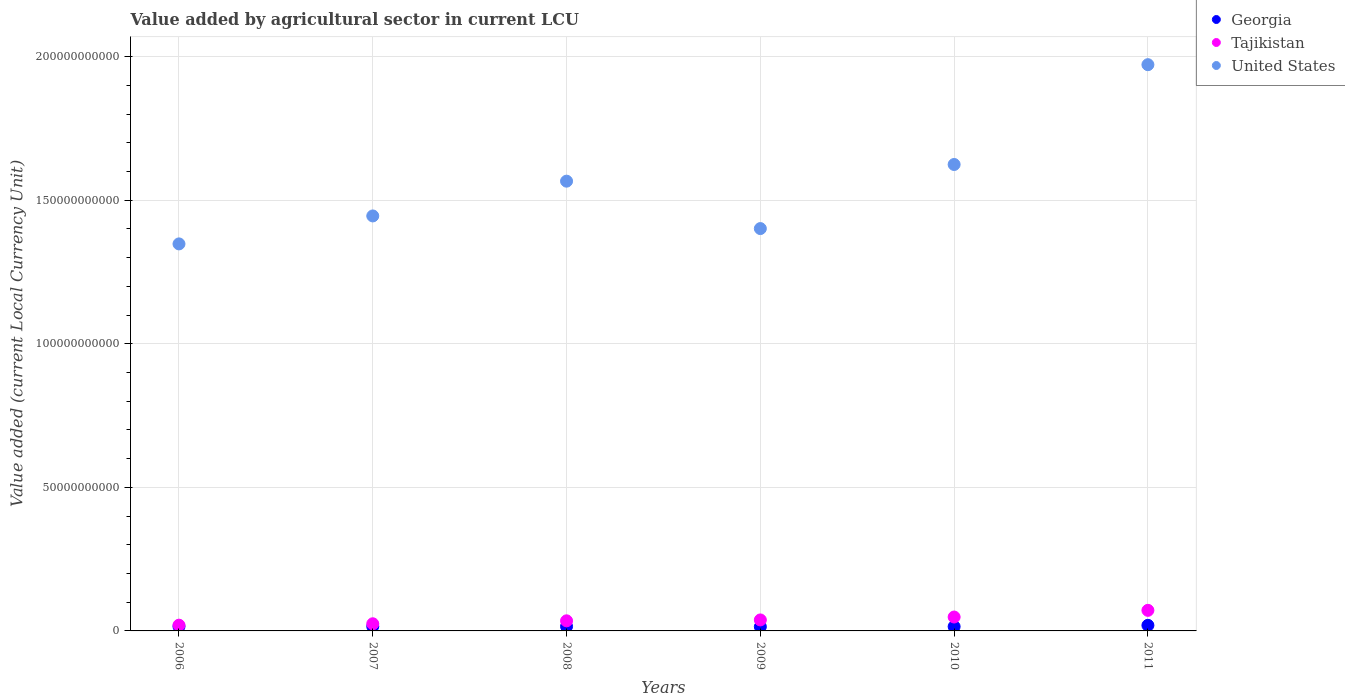What is the value added by agricultural sector in Tajikistan in 2010?
Provide a succinct answer. 4.84e+09. Across all years, what is the maximum value added by agricultural sector in United States?
Your answer should be very brief. 1.97e+11. Across all years, what is the minimum value added by agricultural sector in Tajikistan?
Give a very brief answer. 2.00e+09. What is the total value added by agricultural sector in Tajikistan in the graph?
Your answer should be very brief. 2.38e+1. What is the difference between the value added by agricultural sector in Tajikistan in 2009 and that in 2010?
Keep it short and to the point. -1.01e+09. What is the difference between the value added by agricultural sector in Tajikistan in 2011 and the value added by agricultural sector in Georgia in 2010?
Your response must be concise. 5.66e+09. What is the average value added by agricultural sector in Tajikistan per year?
Your response must be concise. 3.97e+09. In the year 2010, what is the difference between the value added by agricultural sector in United States and value added by agricultural sector in Georgia?
Give a very brief answer. 1.61e+11. What is the ratio of the value added by agricultural sector in Tajikistan in 2007 to that in 2009?
Your answer should be compact. 0.65. Is the value added by agricultural sector in Tajikistan in 2007 less than that in 2010?
Make the answer very short. Yes. Is the difference between the value added by agricultural sector in United States in 2009 and 2010 greater than the difference between the value added by agricultural sector in Georgia in 2009 and 2010?
Provide a short and direct response. No. What is the difference between the highest and the second highest value added by agricultural sector in Tajikistan?
Offer a very short reply. 2.33e+09. What is the difference between the highest and the lowest value added by agricultural sector in Tajikistan?
Your answer should be compact. 5.17e+09. How many dotlines are there?
Your answer should be compact. 3. How many years are there in the graph?
Offer a very short reply. 6. Does the graph contain any zero values?
Provide a succinct answer. No. Where does the legend appear in the graph?
Ensure brevity in your answer.  Top right. How are the legend labels stacked?
Your answer should be compact. Vertical. What is the title of the graph?
Provide a succinct answer. Value added by agricultural sector in current LCU. Does "Lithuania" appear as one of the legend labels in the graph?
Your answer should be very brief. No. What is the label or title of the X-axis?
Offer a terse response. Years. What is the label or title of the Y-axis?
Give a very brief answer. Value added (current Local Currency Unit). What is the Value added (current Local Currency Unit) of Georgia in 2006?
Your response must be concise. 1.54e+09. What is the Value added (current Local Currency Unit) in Tajikistan in 2006?
Your answer should be very brief. 2.00e+09. What is the Value added (current Local Currency Unit) in United States in 2006?
Offer a terse response. 1.35e+11. What is the Value added (current Local Currency Unit) of Georgia in 2007?
Your answer should be compact. 1.56e+09. What is the Value added (current Local Currency Unit) of Tajikistan in 2007?
Keep it short and to the point. 2.49e+09. What is the Value added (current Local Currency Unit) in United States in 2007?
Your answer should be very brief. 1.45e+11. What is the Value added (current Local Currency Unit) in Georgia in 2008?
Provide a short and direct response. 1.55e+09. What is the Value added (current Local Currency Unit) of Tajikistan in 2008?
Offer a terse response. 3.52e+09. What is the Value added (current Local Currency Unit) of United States in 2008?
Ensure brevity in your answer.  1.57e+11. What is the Value added (current Local Currency Unit) of Georgia in 2009?
Ensure brevity in your answer.  1.46e+09. What is the Value added (current Local Currency Unit) of Tajikistan in 2009?
Ensure brevity in your answer.  3.83e+09. What is the Value added (current Local Currency Unit) in United States in 2009?
Keep it short and to the point. 1.40e+11. What is the Value added (current Local Currency Unit) of Georgia in 2010?
Keep it short and to the point. 1.51e+09. What is the Value added (current Local Currency Unit) in Tajikistan in 2010?
Offer a terse response. 4.84e+09. What is the Value added (current Local Currency Unit) of United States in 2010?
Provide a succinct answer. 1.62e+11. What is the Value added (current Local Currency Unit) of Georgia in 2011?
Your answer should be compact. 1.95e+09. What is the Value added (current Local Currency Unit) of Tajikistan in 2011?
Give a very brief answer. 7.17e+09. What is the Value added (current Local Currency Unit) of United States in 2011?
Offer a terse response. 1.97e+11. Across all years, what is the maximum Value added (current Local Currency Unit) in Georgia?
Offer a terse response. 1.95e+09. Across all years, what is the maximum Value added (current Local Currency Unit) in Tajikistan?
Offer a very short reply. 7.17e+09. Across all years, what is the maximum Value added (current Local Currency Unit) in United States?
Offer a terse response. 1.97e+11. Across all years, what is the minimum Value added (current Local Currency Unit) in Georgia?
Your answer should be compact. 1.46e+09. Across all years, what is the minimum Value added (current Local Currency Unit) in Tajikistan?
Your response must be concise. 2.00e+09. Across all years, what is the minimum Value added (current Local Currency Unit) in United States?
Offer a very short reply. 1.35e+11. What is the total Value added (current Local Currency Unit) of Georgia in the graph?
Your answer should be very brief. 9.57e+09. What is the total Value added (current Local Currency Unit) of Tajikistan in the graph?
Provide a succinct answer. 2.38e+1. What is the total Value added (current Local Currency Unit) in United States in the graph?
Your response must be concise. 9.36e+11. What is the difference between the Value added (current Local Currency Unit) in Georgia in 2006 and that in 2007?
Give a very brief answer. -1.84e+07. What is the difference between the Value added (current Local Currency Unit) of Tajikistan in 2006 and that in 2007?
Give a very brief answer. -4.86e+08. What is the difference between the Value added (current Local Currency Unit) in United States in 2006 and that in 2007?
Your response must be concise. -9.74e+09. What is the difference between the Value added (current Local Currency Unit) in Georgia in 2006 and that in 2008?
Provide a succinct answer. -6.71e+06. What is the difference between the Value added (current Local Currency Unit) in Tajikistan in 2006 and that in 2008?
Offer a very short reply. -1.52e+09. What is the difference between the Value added (current Local Currency Unit) in United States in 2006 and that in 2008?
Ensure brevity in your answer.  -2.18e+1. What is the difference between the Value added (current Local Currency Unit) of Georgia in 2006 and that in 2009?
Provide a succinct answer. 8.72e+07. What is the difference between the Value added (current Local Currency Unit) of Tajikistan in 2006 and that in 2009?
Make the answer very short. -1.82e+09. What is the difference between the Value added (current Local Currency Unit) in United States in 2006 and that in 2009?
Your answer should be very brief. -5.34e+09. What is the difference between the Value added (current Local Currency Unit) of Georgia in 2006 and that in 2010?
Offer a terse response. 3.45e+07. What is the difference between the Value added (current Local Currency Unit) in Tajikistan in 2006 and that in 2010?
Your answer should be very brief. -2.84e+09. What is the difference between the Value added (current Local Currency Unit) in United States in 2006 and that in 2010?
Provide a short and direct response. -2.77e+1. What is the difference between the Value added (current Local Currency Unit) in Georgia in 2006 and that in 2011?
Give a very brief answer. -4.02e+08. What is the difference between the Value added (current Local Currency Unit) of Tajikistan in 2006 and that in 2011?
Provide a short and direct response. -5.17e+09. What is the difference between the Value added (current Local Currency Unit) in United States in 2006 and that in 2011?
Provide a short and direct response. -6.24e+1. What is the difference between the Value added (current Local Currency Unit) in Georgia in 2007 and that in 2008?
Offer a very short reply. 1.17e+07. What is the difference between the Value added (current Local Currency Unit) of Tajikistan in 2007 and that in 2008?
Make the answer very short. -1.03e+09. What is the difference between the Value added (current Local Currency Unit) of United States in 2007 and that in 2008?
Give a very brief answer. -1.21e+1. What is the difference between the Value added (current Local Currency Unit) in Georgia in 2007 and that in 2009?
Offer a terse response. 1.06e+08. What is the difference between the Value added (current Local Currency Unit) in Tajikistan in 2007 and that in 2009?
Ensure brevity in your answer.  -1.34e+09. What is the difference between the Value added (current Local Currency Unit) of United States in 2007 and that in 2009?
Give a very brief answer. 4.40e+09. What is the difference between the Value added (current Local Currency Unit) in Georgia in 2007 and that in 2010?
Ensure brevity in your answer.  5.29e+07. What is the difference between the Value added (current Local Currency Unit) in Tajikistan in 2007 and that in 2010?
Offer a very short reply. -2.35e+09. What is the difference between the Value added (current Local Currency Unit) in United States in 2007 and that in 2010?
Your answer should be compact. -1.79e+1. What is the difference between the Value added (current Local Currency Unit) of Georgia in 2007 and that in 2011?
Your answer should be very brief. -3.84e+08. What is the difference between the Value added (current Local Currency Unit) in Tajikistan in 2007 and that in 2011?
Provide a short and direct response. -4.68e+09. What is the difference between the Value added (current Local Currency Unit) of United States in 2007 and that in 2011?
Offer a terse response. -5.27e+1. What is the difference between the Value added (current Local Currency Unit) of Georgia in 2008 and that in 2009?
Your response must be concise. 9.40e+07. What is the difference between the Value added (current Local Currency Unit) of Tajikistan in 2008 and that in 2009?
Your answer should be compact. -3.09e+08. What is the difference between the Value added (current Local Currency Unit) of United States in 2008 and that in 2009?
Provide a short and direct response. 1.65e+1. What is the difference between the Value added (current Local Currency Unit) of Georgia in 2008 and that in 2010?
Ensure brevity in your answer.  4.12e+07. What is the difference between the Value added (current Local Currency Unit) of Tajikistan in 2008 and that in 2010?
Make the answer very short. -1.32e+09. What is the difference between the Value added (current Local Currency Unit) of United States in 2008 and that in 2010?
Keep it short and to the point. -5.81e+09. What is the difference between the Value added (current Local Currency Unit) of Georgia in 2008 and that in 2011?
Offer a very short reply. -3.96e+08. What is the difference between the Value added (current Local Currency Unit) of Tajikistan in 2008 and that in 2011?
Offer a very short reply. -3.65e+09. What is the difference between the Value added (current Local Currency Unit) of United States in 2008 and that in 2011?
Keep it short and to the point. -4.06e+1. What is the difference between the Value added (current Local Currency Unit) in Georgia in 2009 and that in 2010?
Make the answer very short. -5.28e+07. What is the difference between the Value added (current Local Currency Unit) in Tajikistan in 2009 and that in 2010?
Your answer should be compact. -1.01e+09. What is the difference between the Value added (current Local Currency Unit) in United States in 2009 and that in 2010?
Offer a terse response. -2.23e+1. What is the difference between the Value added (current Local Currency Unit) in Georgia in 2009 and that in 2011?
Provide a short and direct response. -4.90e+08. What is the difference between the Value added (current Local Currency Unit) in Tajikistan in 2009 and that in 2011?
Keep it short and to the point. -3.34e+09. What is the difference between the Value added (current Local Currency Unit) of United States in 2009 and that in 2011?
Ensure brevity in your answer.  -5.71e+1. What is the difference between the Value added (current Local Currency Unit) of Georgia in 2010 and that in 2011?
Ensure brevity in your answer.  -4.37e+08. What is the difference between the Value added (current Local Currency Unit) in Tajikistan in 2010 and that in 2011?
Keep it short and to the point. -2.33e+09. What is the difference between the Value added (current Local Currency Unit) in United States in 2010 and that in 2011?
Give a very brief answer. -3.48e+1. What is the difference between the Value added (current Local Currency Unit) of Georgia in 2006 and the Value added (current Local Currency Unit) of Tajikistan in 2007?
Make the answer very short. -9.44e+08. What is the difference between the Value added (current Local Currency Unit) of Georgia in 2006 and the Value added (current Local Currency Unit) of United States in 2007?
Your response must be concise. -1.43e+11. What is the difference between the Value added (current Local Currency Unit) in Tajikistan in 2006 and the Value added (current Local Currency Unit) in United States in 2007?
Your response must be concise. -1.43e+11. What is the difference between the Value added (current Local Currency Unit) of Georgia in 2006 and the Value added (current Local Currency Unit) of Tajikistan in 2008?
Offer a very short reply. -1.97e+09. What is the difference between the Value added (current Local Currency Unit) in Georgia in 2006 and the Value added (current Local Currency Unit) in United States in 2008?
Provide a succinct answer. -1.55e+11. What is the difference between the Value added (current Local Currency Unit) of Tajikistan in 2006 and the Value added (current Local Currency Unit) of United States in 2008?
Ensure brevity in your answer.  -1.55e+11. What is the difference between the Value added (current Local Currency Unit) in Georgia in 2006 and the Value added (current Local Currency Unit) in Tajikistan in 2009?
Ensure brevity in your answer.  -2.28e+09. What is the difference between the Value added (current Local Currency Unit) in Georgia in 2006 and the Value added (current Local Currency Unit) in United States in 2009?
Provide a succinct answer. -1.39e+11. What is the difference between the Value added (current Local Currency Unit) of Tajikistan in 2006 and the Value added (current Local Currency Unit) of United States in 2009?
Keep it short and to the point. -1.38e+11. What is the difference between the Value added (current Local Currency Unit) of Georgia in 2006 and the Value added (current Local Currency Unit) of Tajikistan in 2010?
Keep it short and to the point. -3.29e+09. What is the difference between the Value added (current Local Currency Unit) in Georgia in 2006 and the Value added (current Local Currency Unit) in United States in 2010?
Provide a short and direct response. -1.61e+11. What is the difference between the Value added (current Local Currency Unit) in Tajikistan in 2006 and the Value added (current Local Currency Unit) in United States in 2010?
Make the answer very short. -1.60e+11. What is the difference between the Value added (current Local Currency Unit) in Georgia in 2006 and the Value added (current Local Currency Unit) in Tajikistan in 2011?
Provide a succinct answer. -5.62e+09. What is the difference between the Value added (current Local Currency Unit) in Georgia in 2006 and the Value added (current Local Currency Unit) in United States in 2011?
Your answer should be very brief. -1.96e+11. What is the difference between the Value added (current Local Currency Unit) in Tajikistan in 2006 and the Value added (current Local Currency Unit) in United States in 2011?
Your response must be concise. -1.95e+11. What is the difference between the Value added (current Local Currency Unit) of Georgia in 2007 and the Value added (current Local Currency Unit) of Tajikistan in 2008?
Provide a succinct answer. -1.96e+09. What is the difference between the Value added (current Local Currency Unit) of Georgia in 2007 and the Value added (current Local Currency Unit) of United States in 2008?
Offer a very short reply. -1.55e+11. What is the difference between the Value added (current Local Currency Unit) of Tajikistan in 2007 and the Value added (current Local Currency Unit) of United States in 2008?
Make the answer very short. -1.54e+11. What is the difference between the Value added (current Local Currency Unit) of Georgia in 2007 and the Value added (current Local Currency Unit) of Tajikistan in 2009?
Make the answer very short. -2.26e+09. What is the difference between the Value added (current Local Currency Unit) in Georgia in 2007 and the Value added (current Local Currency Unit) in United States in 2009?
Your answer should be compact. -1.39e+11. What is the difference between the Value added (current Local Currency Unit) of Tajikistan in 2007 and the Value added (current Local Currency Unit) of United States in 2009?
Ensure brevity in your answer.  -1.38e+11. What is the difference between the Value added (current Local Currency Unit) of Georgia in 2007 and the Value added (current Local Currency Unit) of Tajikistan in 2010?
Keep it short and to the point. -3.28e+09. What is the difference between the Value added (current Local Currency Unit) in Georgia in 2007 and the Value added (current Local Currency Unit) in United States in 2010?
Ensure brevity in your answer.  -1.61e+11. What is the difference between the Value added (current Local Currency Unit) of Tajikistan in 2007 and the Value added (current Local Currency Unit) of United States in 2010?
Ensure brevity in your answer.  -1.60e+11. What is the difference between the Value added (current Local Currency Unit) of Georgia in 2007 and the Value added (current Local Currency Unit) of Tajikistan in 2011?
Give a very brief answer. -5.60e+09. What is the difference between the Value added (current Local Currency Unit) of Georgia in 2007 and the Value added (current Local Currency Unit) of United States in 2011?
Provide a short and direct response. -1.96e+11. What is the difference between the Value added (current Local Currency Unit) in Tajikistan in 2007 and the Value added (current Local Currency Unit) in United States in 2011?
Your answer should be very brief. -1.95e+11. What is the difference between the Value added (current Local Currency Unit) in Georgia in 2008 and the Value added (current Local Currency Unit) in Tajikistan in 2009?
Your answer should be compact. -2.28e+09. What is the difference between the Value added (current Local Currency Unit) of Georgia in 2008 and the Value added (current Local Currency Unit) of United States in 2009?
Make the answer very short. -1.39e+11. What is the difference between the Value added (current Local Currency Unit) in Tajikistan in 2008 and the Value added (current Local Currency Unit) in United States in 2009?
Your answer should be very brief. -1.37e+11. What is the difference between the Value added (current Local Currency Unit) in Georgia in 2008 and the Value added (current Local Currency Unit) in Tajikistan in 2010?
Your answer should be compact. -3.29e+09. What is the difference between the Value added (current Local Currency Unit) of Georgia in 2008 and the Value added (current Local Currency Unit) of United States in 2010?
Offer a terse response. -1.61e+11. What is the difference between the Value added (current Local Currency Unit) in Tajikistan in 2008 and the Value added (current Local Currency Unit) in United States in 2010?
Make the answer very short. -1.59e+11. What is the difference between the Value added (current Local Currency Unit) in Georgia in 2008 and the Value added (current Local Currency Unit) in Tajikistan in 2011?
Offer a very short reply. -5.62e+09. What is the difference between the Value added (current Local Currency Unit) of Georgia in 2008 and the Value added (current Local Currency Unit) of United States in 2011?
Provide a succinct answer. -1.96e+11. What is the difference between the Value added (current Local Currency Unit) of Tajikistan in 2008 and the Value added (current Local Currency Unit) of United States in 2011?
Your answer should be very brief. -1.94e+11. What is the difference between the Value added (current Local Currency Unit) in Georgia in 2009 and the Value added (current Local Currency Unit) in Tajikistan in 2010?
Make the answer very short. -3.38e+09. What is the difference between the Value added (current Local Currency Unit) in Georgia in 2009 and the Value added (current Local Currency Unit) in United States in 2010?
Provide a short and direct response. -1.61e+11. What is the difference between the Value added (current Local Currency Unit) of Tajikistan in 2009 and the Value added (current Local Currency Unit) of United States in 2010?
Your answer should be compact. -1.59e+11. What is the difference between the Value added (current Local Currency Unit) in Georgia in 2009 and the Value added (current Local Currency Unit) in Tajikistan in 2011?
Your answer should be compact. -5.71e+09. What is the difference between the Value added (current Local Currency Unit) in Georgia in 2009 and the Value added (current Local Currency Unit) in United States in 2011?
Keep it short and to the point. -1.96e+11. What is the difference between the Value added (current Local Currency Unit) of Tajikistan in 2009 and the Value added (current Local Currency Unit) of United States in 2011?
Give a very brief answer. -1.93e+11. What is the difference between the Value added (current Local Currency Unit) of Georgia in 2010 and the Value added (current Local Currency Unit) of Tajikistan in 2011?
Make the answer very short. -5.66e+09. What is the difference between the Value added (current Local Currency Unit) of Georgia in 2010 and the Value added (current Local Currency Unit) of United States in 2011?
Provide a short and direct response. -1.96e+11. What is the difference between the Value added (current Local Currency Unit) in Tajikistan in 2010 and the Value added (current Local Currency Unit) in United States in 2011?
Your response must be concise. -1.92e+11. What is the average Value added (current Local Currency Unit) of Georgia per year?
Offer a very short reply. 1.60e+09. What is the average Value added (current Local Currency Unit) in Tajikistan per year?
Provide a succinct answer. 3.97e+09. What is the average Value added (current Local Currency Unit) in United States per year?
Make the answer very short. 1.56e+11. In the year 2006, what is the difference between the Value added (current Local Currency Unit) in Georgia and Value added (current Local Currency Unit) in Tajikistan?
Offer a terse response. -4.58e+08. In the year 2006, what is the difference between the Value added (current Local Currency Unit) in Georgia and Value added (current Local Currency Unit) in United States?
Offer a very short reply. -1.33e+11. In the year 2006, what is the difference between the Value added (current Local Currency Unit) in Tajikistan and Value added (current Local Currency Unit) in United States?
Your answer should be compact. -1.33e+11. In the year 2007, what is the difference between the Value added (current Local Currency Unit) of Georgia and Value added (current Local Currency Unit) of Tajikistan?
Ensure brevity in your answer.  -9.26e+08. In the year 2007, what is the difference between the Value added (current Local Currency Unit) of Georgia and Value added (current Local Currency Unit) of United States?
Provide a short and direct response. -1.43e+11. In the year 2007, what is the difference between the Value added (current Local Currency Unit) in Tajikistan and Value added (current Local Currency Unit) in United States?
Your response must be concise. -1.42e+11. In the year 2008, what is the difference between the Value added (current Local Currency Unit) in Georgia and Value added (current Local Currency Unit) in Tajikistan?
Offer a terse response. -1.97e+09. In the year 2008, what is the difference between the Value added (current Local Currency Unit) of Georgia and Value added (current Local Currency Unit) of United States?
Offer a very short reply. -1.55e+11. In the year 2008, what is the difference between the Value added (current Local Currency Unit) of Tajikistan and Value added (current Local Currency Unit) of United States?
Ensure brevity in your answer.  -1.53e+11. In the year 2009, what is the difference between the Value added (current Local Currency Unit) in Georgia and Value added (current Local Currency Unit) in Tajikistan?
Provide a short and direct response. -2.37e+09. In the year 2009, what is the difference between the Value added (current Local Currency Unit) of Georgia and Value added (current Local Currency Unit) of United States?
Make the answer very short. -1.39e+11. In the year 2009, what is the difference between the Value added (current Local Currency Unit) in Tajikistan and Value added (current Local Currency Unit) in United States?
Ensure brevity in your answer.  -1.36e+11. In the year 2010, what is the difference between the Value added (current Local Currency Unit) in Georgia and Value added (current Local Currency Unit) in Tajikistan?
Offer a terse response. -3.33e+09. In the year 2010, what is the difference between the Value added (current Local Currency Unit) of Georgia and Value added (current Local Currency Unit) of United States?
Provide a short and direct response. -1.61e+11. In the year 2010, what is the difference between the Value added (current Local Currency Unit) in Tajikistan and Value added (current Local Currency Unit) in United States?
Your answer should be very brief. -1.58e+11. In the year 2011, what is the difference between the Value added (current Local Currency Unit) in Georgia and Value added (current Local Currency Unit) in Tajikistan?
Ensure brevity in your answer.  -5.22e+09. In the year 2011, what is the difference between the Value added (current Local Currency Unit) in Georgia and Value added (current Local Currency Unit) in United States?
Make the answer very short. -1.95e+11. In the year 2011, what is the difference between the Value added (current Local Currency Unit) of Tajikistan and Value added (current Local Currency Unit) of United States?
Provide a succinct answer. -1.90e+11. What is the ratio of the Value added (current Local Currency Unit) in Tajikistan in 2006 to that in 2007?
Make the answer very short. 0.8. What is the ratio of the Value added (current Local Currency Unit) of United States in 2006 to that in 2007?
Provide a succinct answer. 0.93. What is the ratio of the Value added (current Local Currency Unit) in Tajikistan in 2006 to that in 2008?
Ensure brevity in your answer.  0.57. What is the ratio of the Value added (current Local Currency Unit) in United States in 2006 to that in 2008?
Offer a very short reply. 0.86. What is the ratio of the Value added (current Local Currency Unit) in Georgia in 2006 to that in 2009?
Provide a succinct answer. 1.06. What is the ratio of the Value added (current Local Currency Unit) in Tajikistan in 2006 to that in 2009?
Ensure brevity in your answer.  0.52. What is the ratio of the Value added (current Local Currency Unit) in United States in 2006 to that in 2009?
Your answer should be compact. 0.96. What is the ratio of the Value added (current Local Currency Unit) in Georgia in 2006 to that in 2010?
Your response must be concise. 1.02. What is the ratio of the Value added (current Local Currency Unit) of Tajikistan in 2006 to that in 2010?
Your answer should be compact. 0.41. What is the ratio of the Value added (current Local Currency Unit) in United States in 2006 to that in 2010?
Give a very brief answer. 0.83. What is the ratio of the Value added (current Local Currency Unit) of Georgia in 2006 to that in 2011?
Provide a succinct answer. 0.79. What is the ratio of the Value added (current Local Currency Unit) of Tajikistan in 2006 to that in 2011?
Give a very brief answer. 0.28. What is the ratio of the Value added (current Local Currency Unit) in United States in 2006 to that in 2011?
Keep it short and to the point. 0.68. What is the ratio of the Value added (current Local Currency Unit) in Georgia in 2007 to that in 2008?
Provide a succinct answer. 1.01. What is the ratio of the Value added (current Local Currency Unit) of Tajikistan in 2007 to that in 2008?
Your response must be concise. 0.71. What is the ratio of the Value added (current Local Currency Unit) of United States in 2007 to that in 2008?
Your answer should be compact. 0.92. What is the ratio of the Value added (current Local Currency Unit) in Georgia in 2007 to that in 2009?
Offer a very short reply. 1.07. What is the ratio of the Value added (current Local Currency Unit) of Tajikistan in 2007 to that in 2009?
Your answer should be very brief. 0.65. What is the ratio of the Value added (current Local Currency Unit) in United States in 2007 to that in 2009?
Offer a very short reply. 1.03. What is the ratio of the Value added (current Local Currency Unit) in Georgia in 2007 to that in 2010?
Give a very brief answer. 1.03. What is the ratio of the Value added (current Local Currency Unit) in Tajikistan in 2007 to that in 2010?
Provide a succinct answer. 0.51. What is the ratio of the Value added (current Local Currency Unit) of United States in 2007 to that in 2010?
Offer a terse response. 0.89. What is the ratio of the Value added (current Local Currency Unit) in Georgia in 2007 to that in 2011?
Your response must be concise. 0.8. What is the ratio of the Value added (current Local Currency Unit) of Tajikistan in 2007 to that in 2011?
Offer a terse response. 0.35. What is the ratio of the Value added (current Local Currency Unit) in United States in 2007 to that in 2011?
Your answer should be very brief. 0.73. What is the ratio of the Value added (current Local Currency Unit) of Georgia in 2008 to that in 2009?
Your answer should be very brief. 1.06. What is the ratio of the Value added (current Local Currency Unit) in Tajikistan in 2008 to that in 2009?
Offer a very short reply. 0.92. What is the ratio of the Value added (current Local Currency Unit) in United States in 2008 to that in 2009?
Keep it short and to the point. 1.12. What is the ratio of the Value added (current Local Currency Unit) in Georgia in 2008 to that in 2010?
Make the answer very short. 1.03. What is the ratio of the Value added (current Local Currency Unit) in Tajikistan in 2008 to that in 2010?
Provide a short and direct response. 0.73. What is the ratio of the Value added (current Local Currency Unit) in United States in 2008 to that in 2010?
Give a very brief answer. 0.96. What is the ratio of the Value added (current Local Currency Unit) of Georgia in 2008 to that in 2011?
Make the answer very short. 0.8. What is the ratio of the Value added (current Local Currency Unit) in Tajikistan in 2008 to that in 2011?
Your response must be concise. 0.49. What is the ratio of the Value added (current Local Currency Unit) of United States in 2008 to that in 2011?
Give a very brief answer. 0.79. What is the ratio of the Value added (current Local Currency Unit) of Georgia in 2009 to that in 2010?
Your answer should be very brief. 0.97. What is the ratio of the Value added (current Local Currency Unit) in Tajikistan in 2009 to that in 2010?
Provide a short and direct response. 0.79. What is the ratio of the Value added (current Local Currency Unit) in United States in 2009 to that in 2010?
Make the answer very short. 0.86. What is the ratio of the Value added (current Local Currency Unit) of Georgia in 2009 to that in 2011?
Provide a short and direct response. 0.75. What is the ratio of the Value added (current Local Currency Unit) in Tajikistan in 2009 to that in 2011?
Offer a very short reply. 0.53. What is the ratio of the Value added (current Local Currency Unit) in United States in 2009 to that in 2011?
Keep it short and to the point. 0.71. What is the ratio of the Value added (current Local Currency Unit) in Georgia in 2010 to that in 2011?
Your answer should be very brief. 0.78. What is the ratio of the Value added (current Local Currency Unit) of Tajikistan in 2010 to that in 2011?
Provide a short and direct response. 0.68. What is the ratio of the Value added (current Local Currency Unit) in United States in 2010 to that in 2011?
Give a very brief answer. 0.82. What is the difference between the highest and the second highest Value added (current Local Currency Unit) of Georgia?
Provide a succinct answer. 3.84e+08. What is the difference between the highest and the second highest Value added (current Local Currency Unit) in Tajikistan?
Your answer should be compact. 2.33e+09. What is the difference between the highest and the second highest Value added (current Local Currency Unit) of United States?
Provide a succinct answer. 3.48e+1. What is the difference between the highest and the lowest Value added (current Local Currency Unit) of Georgia?
Keep it short and to the point. 4.90e+08. What is the difference between the highest and the lowest Value added (current Local Currency Unit) in Tajikistan?
Offer a very short reply. 5.17e+09. What is the difference between the highest and the lowest Value added (current Local Currency Unit) in United States?
Provide a short and direct response. 6.24e+1. 